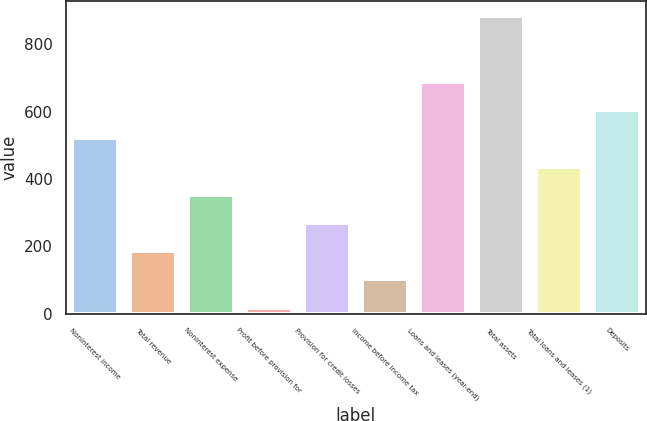Convert chart. <chart><loc_0><loc_0><loc_500><loc_500><bar_chart><fcel>Noninterest income<fcel>Total revenue<fcel>Noninterest expense<fcel>Profit before provision for<fcel>Provision for credit losses<fcel>Income before income tax<fcel>Loans and leases (year-end)<fcel>Total assets<fcel>Total loans and leases (1)<fcel>Deposits<nl><fcel>520.8<fcel>185.6<fcel>353.2<fcel>18<fcel>269.4<fcel>101.8<fcel>688.4<fcel>884.8<fcel>437<fcel>604.6<nl></chart> 